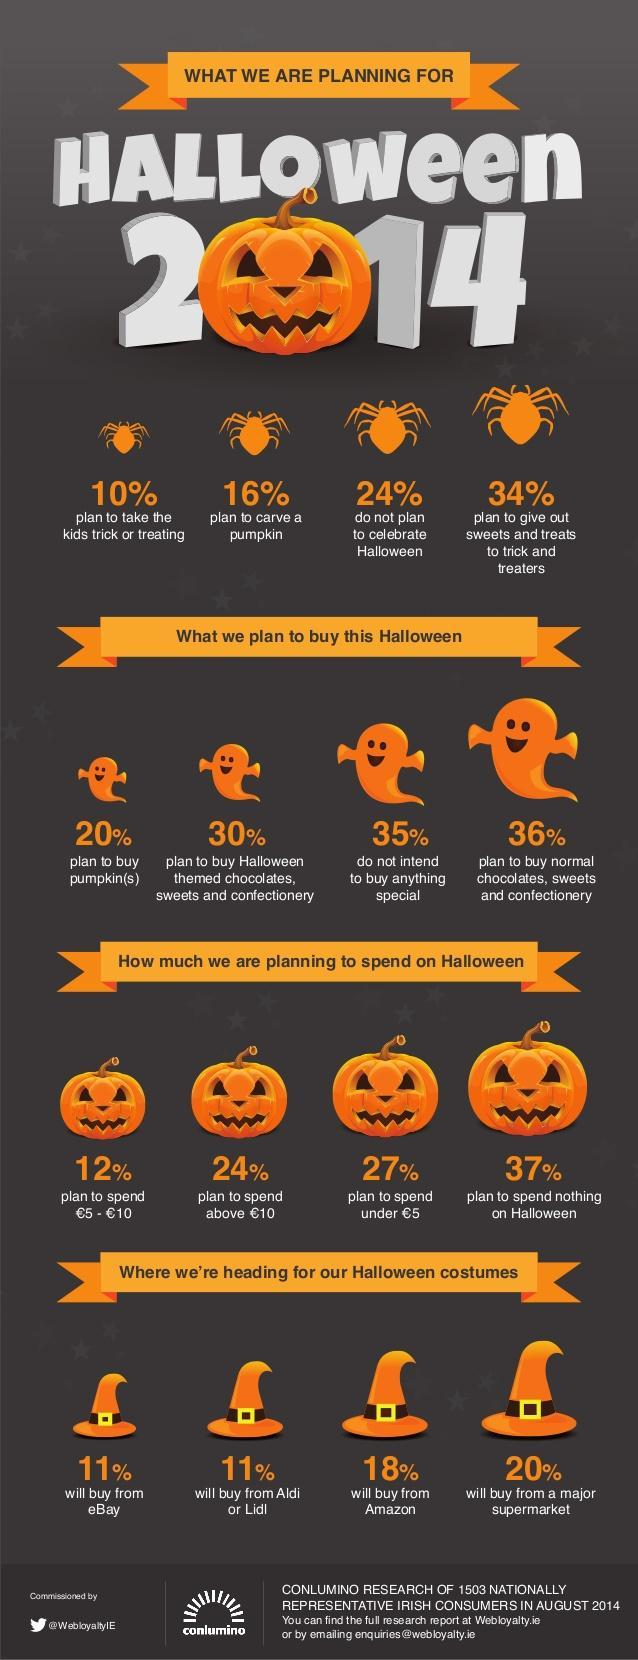Where is the second popular place from where people are going to buy their Halloween costumes from?
Answer the question with a short phrase. Amazon How many people are planning to spend above 10 euros on Halloween? 24% Which is the third most popular activity that people are going to do for Halloween? plan to carve a pumpkin What are people planning to buy the least in the list in the infographic? pumpkin(s) How many people are not planning celebrate Halloween in 2014? 24% What are 1 in 10 people planning to do for Halloween? take the kids trick or treating Where are most people going to buy their Halloween costumes from? major supermarket What are people planning to buy the most? normal chocolates,sweets and confectionary 